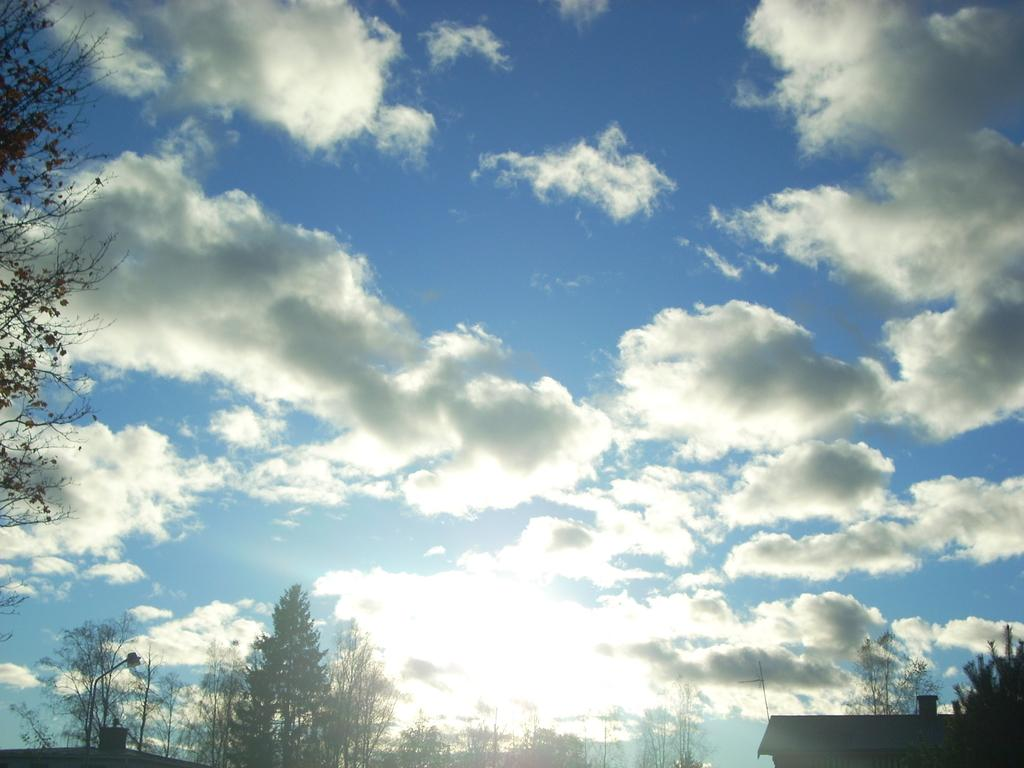What can be seen at the top of the image? The sky is visible in the image. What is located at the bottom of the image? There is a group of trees at the bottom of the image. What type of structures are present in the image? There are buildings in the image. What is attached to the street pole in the image? A light is present on the street pole in the image. Where is the tree located in the image? There is a tree on the left side of the image. What type of cord is attached to the drum in the image? There is no drum present in the image. How many pizzas are visible on the street pole in the image? There are no pizzas present in the image; only a light is attached to the street pole. 